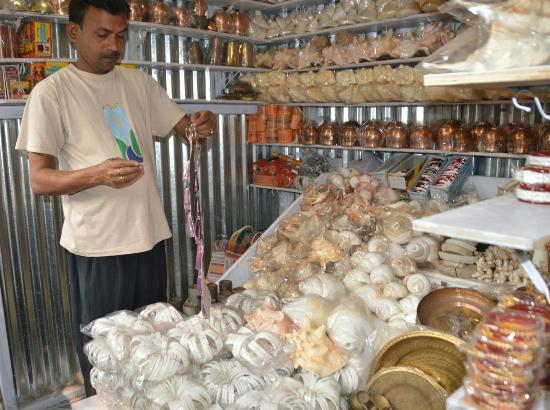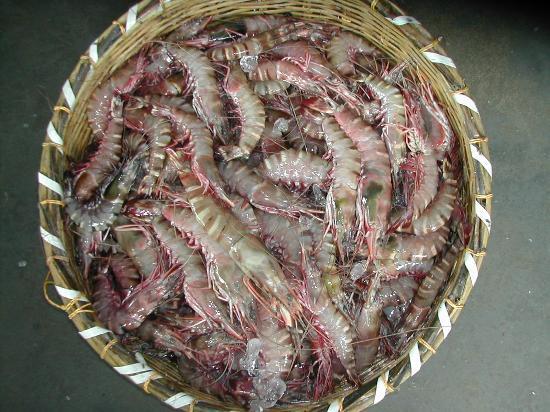The first image is the image on the left, the second image is the image on the right. Assess this claim about the two images: "There are at least two crabs with blue and red colors on it.". Correct or not? Answer yes or no. No. The first image is the image on the left, the second image is the image on the right. Given the left and right images, does the statement "There are at least three crabs in the image pair." hold true? Answer yes or no. No. 